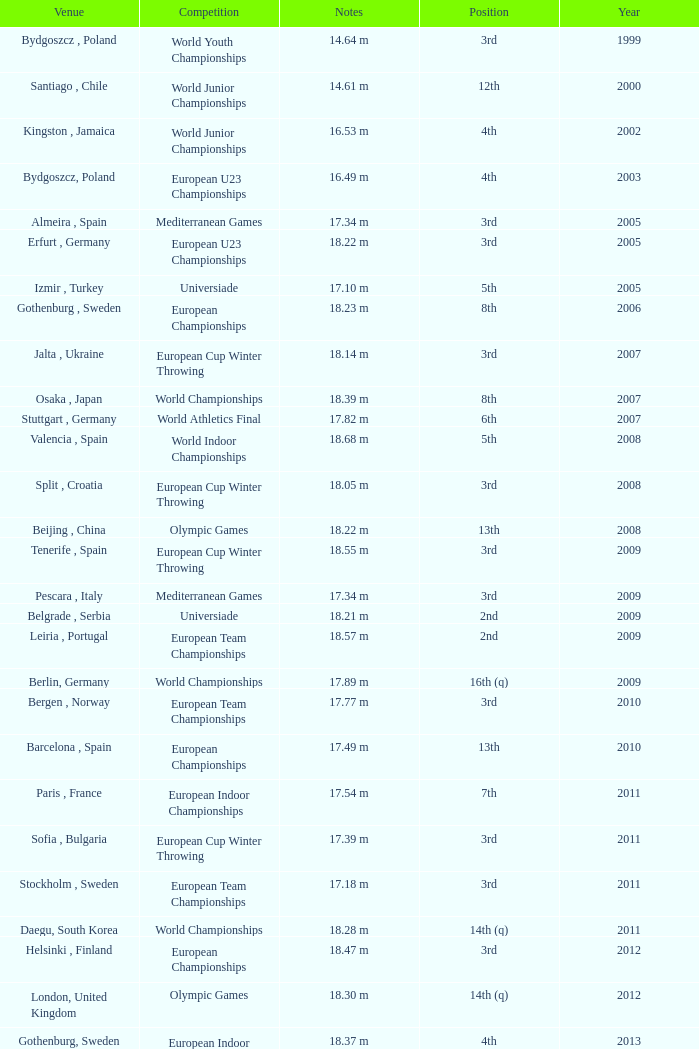What position is 1999? 3rd. 